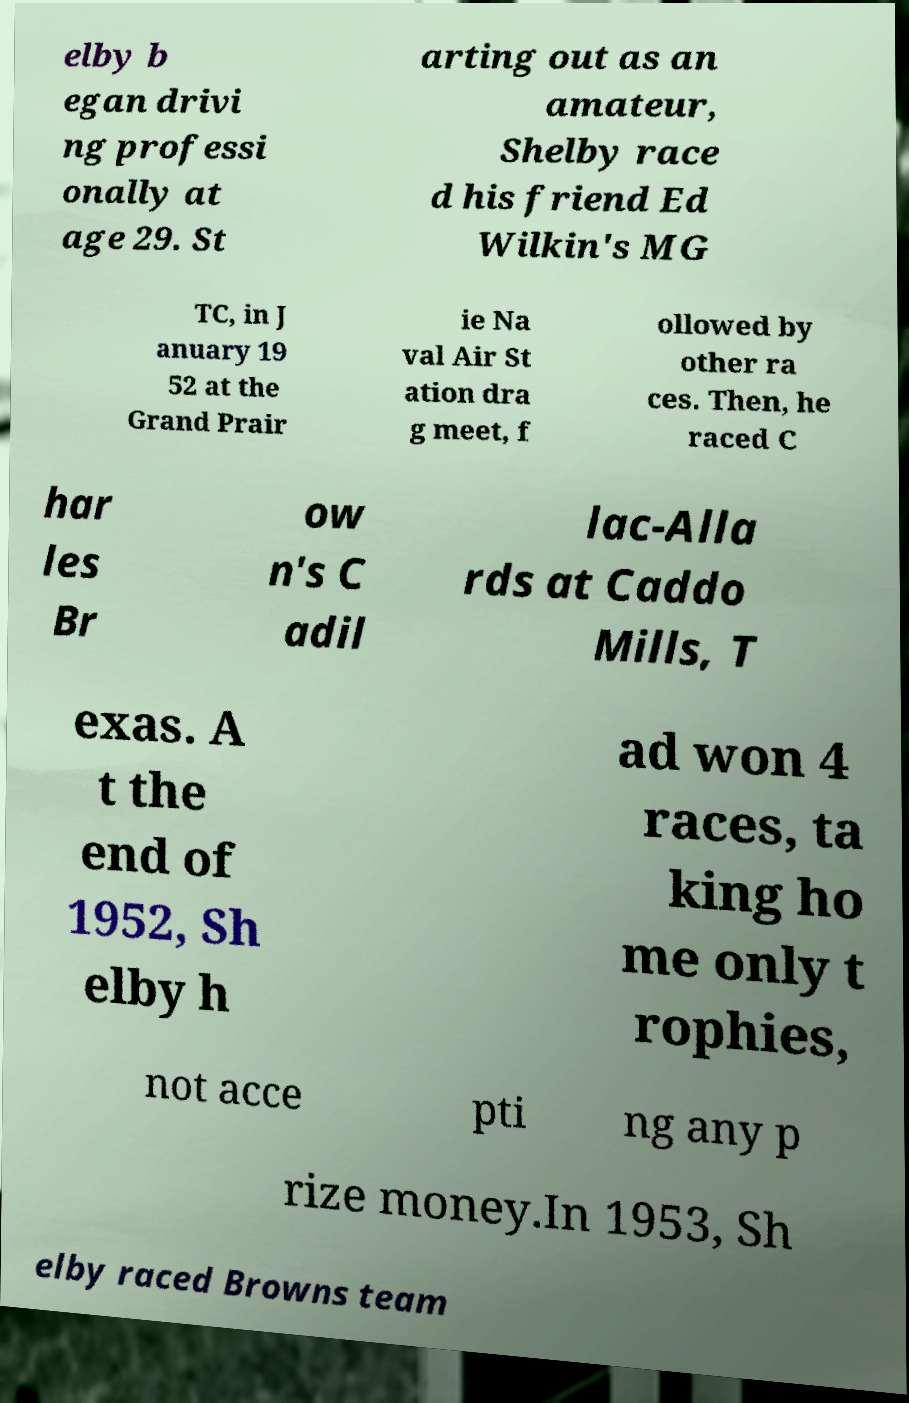Can you accurately transcribe the text from the provided image for me? elby b egan drivi ng professi onally at age 29. St arting out as an amateur, Shelby race d his friend Ed Wilkin's MG TC, in J anuary 19 52 at the Grand Prair ie Na val Air St ation dra g meet, f ollowed by other ra ces. Then, he raced C har les Br ow n's C adil lac-Alla rds at Caddo Mills, T exas. A t the end of 1952, Sh elby h ad won 4 races, ta king ho me only t rophies, not acce pti ng any p rize money.In 1953, Sh elby raced Browns team 